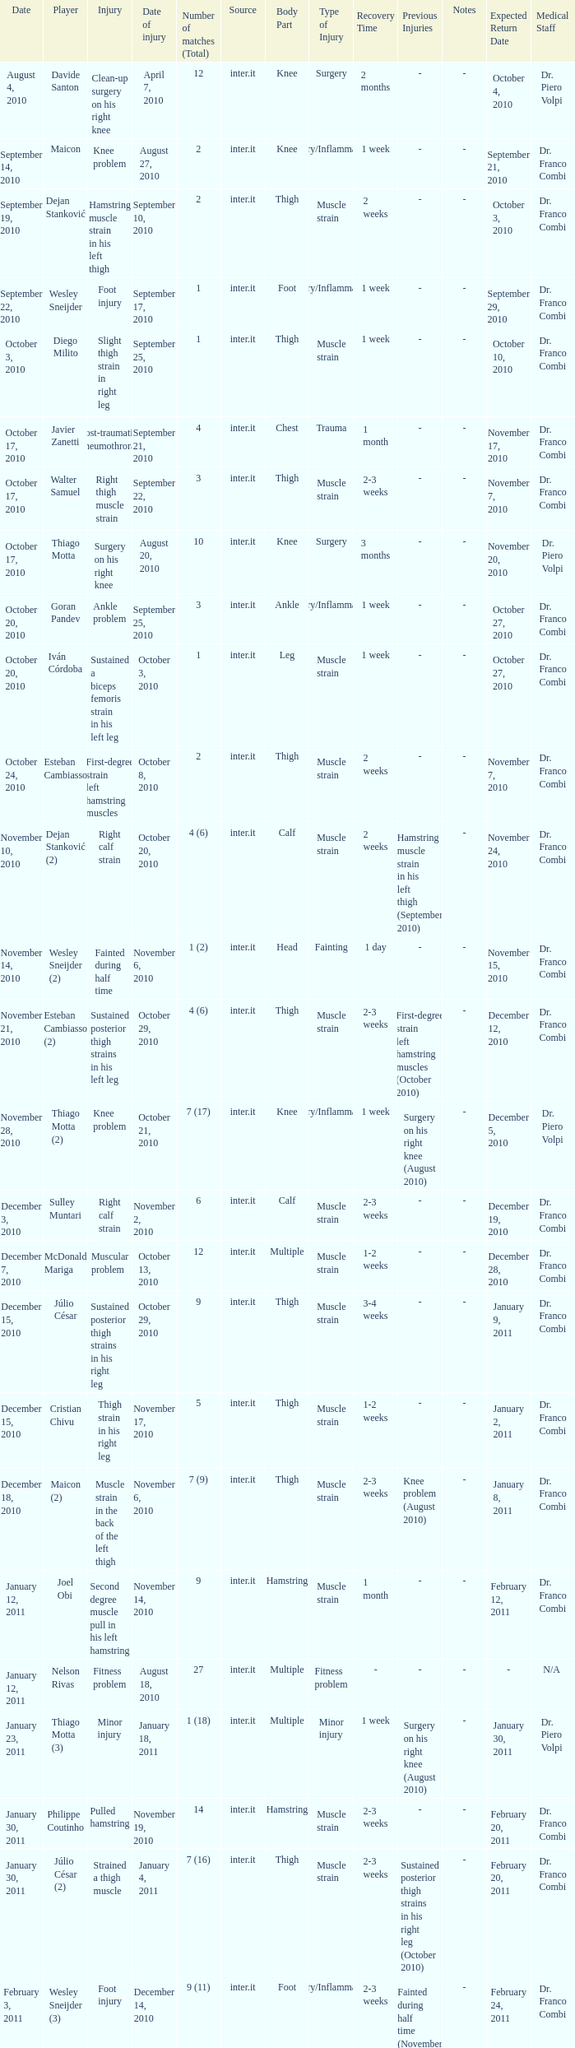What is the date of injury for player Wesley sneijder (2)? November 6, 2010. 